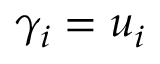<formula> <loc_0><loc_0><loc_500><loc_500>\gamma _ { i } = u _ { i }</formula> 